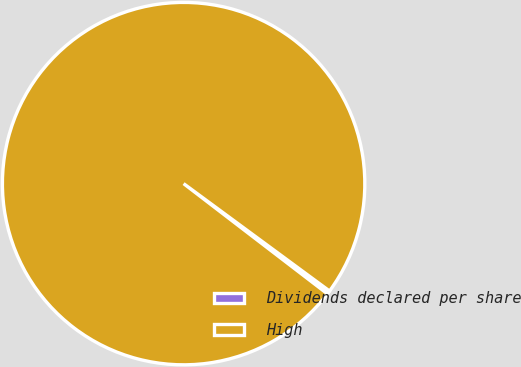<chart> <loc_0><loc_0><loc_500><loc_500><pie_chart><fcel>Dividends declared per share<fcel>High<nl><fcel>0.31%<fcel>99.69%<nl></chart> 